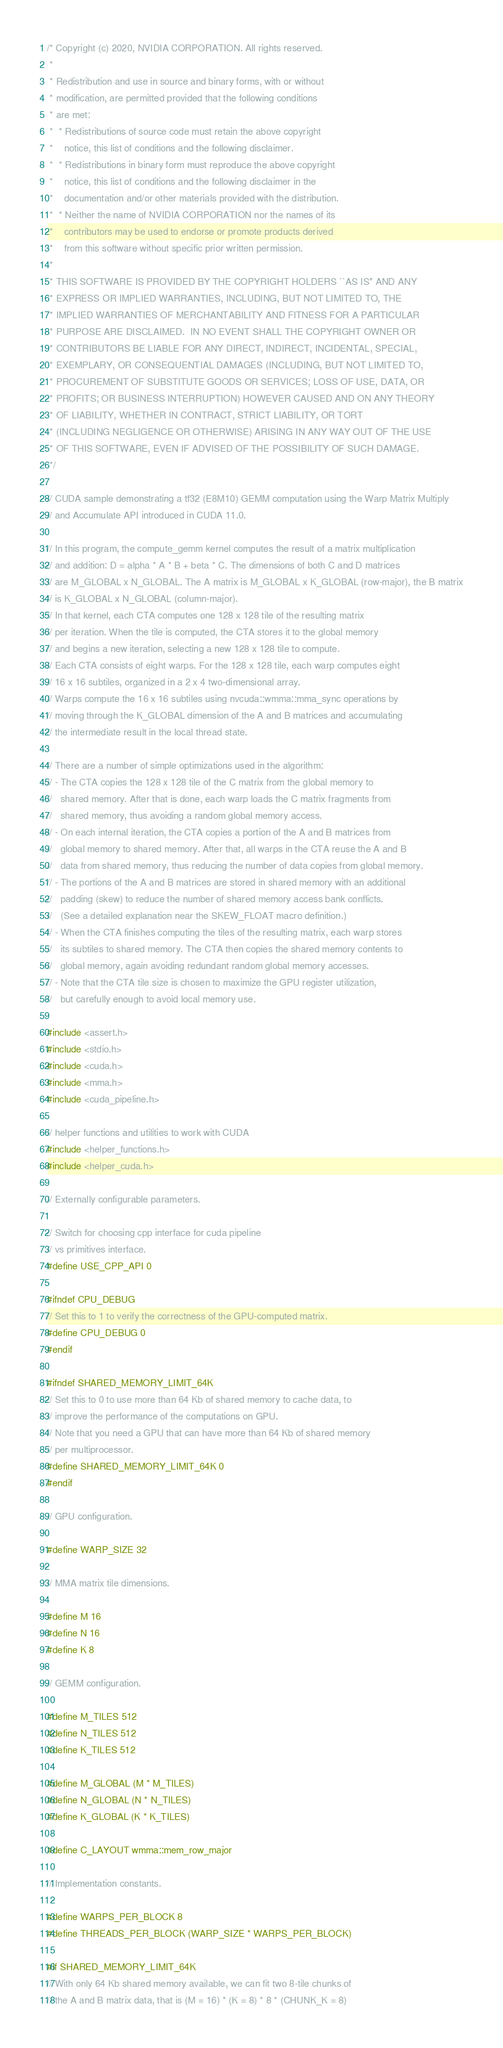Convert code to text. <code><loc_0><loc_0><loc_500><loc_500><_Cuda_>/* Copyright (c) 2020, NVIDIA CORPORATION. All rights reserved.
 *
 * Redistribution and use in source and binary forms, with or without
 * modification, are permitted provided that the following conditions
 * are met:
 *  * Redistributions of source code must retain the above copyright
 *    notice, this list of conditions and the following disclaimer.
 *  * Redistributions in binary form must reproduce the above copyright
 *    notice, this list of conditions and the following disclaimer in the
 *    documentation and/or other materials provided with the distribution.
 *  * Neither the name of NVIDIA CORPORATION nor the names of its
 *    contributors may be used to endorse or promote products derived
 *    from this software without specific prior written permission.
 *
 * THIS SOFTWARE IS PROVIDED BY THE COPYRIGHT HOLDERS ``AS IS'' AND ANY
 * EXPRESS OR IMPLIED WARRANTIES, INCLUDING, BUT NOT LIMITED TO, THE
 * IMPLIED WARRANTIES OF MERCHANTABILITY AND FITNESS FOR A PARTICULAR
 * PURPOSE ARE DISCLAIMED.  IN NO EVENT SHALL THE COPYRIGHT OWNER OR
 * CONTRIBUTORS BE LIABLE FOR ANY DIRECT, INDIRECT, INCIDENTAL, SPECIAL,
 * EXEMPLARY, OR CONSEQUENTIAL DAMAGES (INCLUDING, BUT NOT LIMITED TO,
 * PROCUREMENT OF SUBSTITUTE GOODS OR SERVICES; LOSS OF USE, DATA, OR
 * PROFITS; OR BUSINESS INTERRUPTION) HOWEVER CAUSED AND ON ANY THEORY
 * OF LIABILITY, WHETHER IN CONTRACT, STRICT LIABILITY, OR TORT
 * (INCLUDING NEGLIGENCE OR OTHERWISE) ARISING IN ANY WAY OUT OF THE USE
 * OF THIS SOFTWARE, EVEN IF ADVISED OF THE POSSIBILITY OF SUCH DAMAGE.
 */

// CUDA sample demonstrating a tf32 (E8M10) GEMM computation using the Warp Matrix Multiply
// and Accumulate API introduced in CUDA 11.0.

// In this program, the compute_gemm kernel computes the result of a matrix multiplication
// and addition: D = alpha * A * B + beta * C. The dimensions of both C and D matrices
// are M_GLOBAL x N_GLOBAL. The A matrix is M_GLOBAL x K_GLOBAL (row-major), the B matrix
// is K_GLOBAL x N_GLOBAL (column-major).
// In that kernel, each CTA computes one 128 x 128 tile of the resulting matrix
// per iteration. When the tile is computed, the CTA stores it to the global memory
// and begins a new iteration, selecting a new 128 x 128 tile to compute.
// Each CTA consists of eight warps. For the 128 x 128 tile, each warp computes eight
// 16 x 16 subtiles, organized in a 2 x 4 two-dimensional array.
// Warps compute the 16 x 16 subtiles using nvcuda::wmma::mma_sync operations by
// moving through the K_GLOBAL dimension of the A and B matrices and accumulating
// the intermediate result in the local thread state.

// There are a number of simple optimizations used in the algorithm:
// - The CTA copies the 128 x 128 tile of the C matrix from the global memory to
//   shared memory. After that is done, each warp loads the C matrix fragments from
//   shared memory, thus avoiding a random global memory access.
// - On each internal iteration, the CTA copies a portion of the A and B matrices from
//   global memory to shared memory. After that, all warps in the CTA reuse the A and B
//   data from shared memory, thus reducing the number of data copies from global memory.
// - The portions of the A and B matrices are stored in shared memory with an additional
//   padding (skew) to reduce the number of shared memory access bank conflicts.
//   (See a detailed explanation near the SKEW_FLOAT macro definition.)
// - When the CTA finishes computing the tiles of the resulting matrix, each warp stores
//   its subtiles to shared memory. The CTA then copies the shared memory contents to
//   global memory, again avoiding redundant random global memory accesses.
// - Note that the CTA tile size is chosen to maximize the GPU register utilization,
//   but carefully enough to avoid local memory use.

#include <assert.h>
#include <stdio.h>
#include <cuda.h>
#include <mma.h>
#include <cuda_pipeline.h>

// helper functions and utilities to work with CUDA
#include <helper_functions.h>
#include <helper_cuda.h>

// Externally configurable parameters.

// Switch for choosing cpp interface for cuda pipeline 
// vs primitives interface.
#define USE_CPP_API 0

#ifndef CPU_DEBUG
// Set this to 1 to verify the correctness of the GPU-computed matrix.
#define CPU_DEBUG 0
#endif

#ifndef SHARED_MEMORY_LIMIT_64K
// Set this to 0 to use more than 64 Kb of shared memory to cache data, to
// improve the performance of the computations on GPU.
// Note that you need a GPU that can have more than 64 Kb of shared memory
// per multiprocessor.
#define SHARED_MEMORY_LIMIT_64K 0
#endif

// GPU configuration.

#define WARP_SIZE 32

// MMA matrix tile dimensions.

#define M 16
#define N 16
#define K 8

// GEMM configuration.

#define M_TILES 512
#define N_TILES 512
#define K_TILES 512

#define M_GLOBAL (M * M_TILES)
#define N_GLOBAL (N * N_TILES)
#define K_GLOBAL (K * K_TILES)

#define C_LAYOUT wmma::mem_row_major

// Implementation constants.

#define WARPS_PER_BLOCK 8
#define THREADS_PER_BLOCK (WARP_SIZE * WARPS_PER_BLOCK)

#if SHARED_MEMORY_LIMIT_64K
// With only 64 Kb shared memory available, we can fit two 8-tile chunks of
// the A and B matrix data, that is (M = 16) * (K = 8) * 8 * (CHUNK_K = 8)</code> 